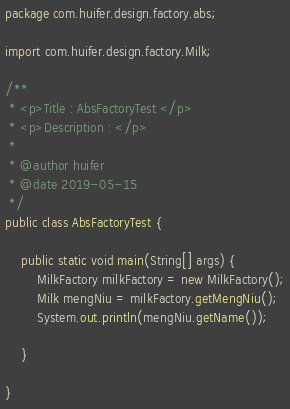<code> <loc_0><loc_0><loc_500><loc_500><_Java_>package com.huifer.design.factory.abs;

import com.huifer.design.factory.Milk;

/**
 * <p>Title : AbsFactoryTest </p>
 * <p>Description : </p>
 *
 * @author huifer
 * @date 2019-05-15
 */
public class AbsFactoryTest {

    public static void main(String[] args) {
        MilkFactory milkFactory = new MilkFactory();
        Milk mengNiu = milkFactory.getMengNiu();
        System.out.println(mengNiu.getName());

    }

}
</code> 